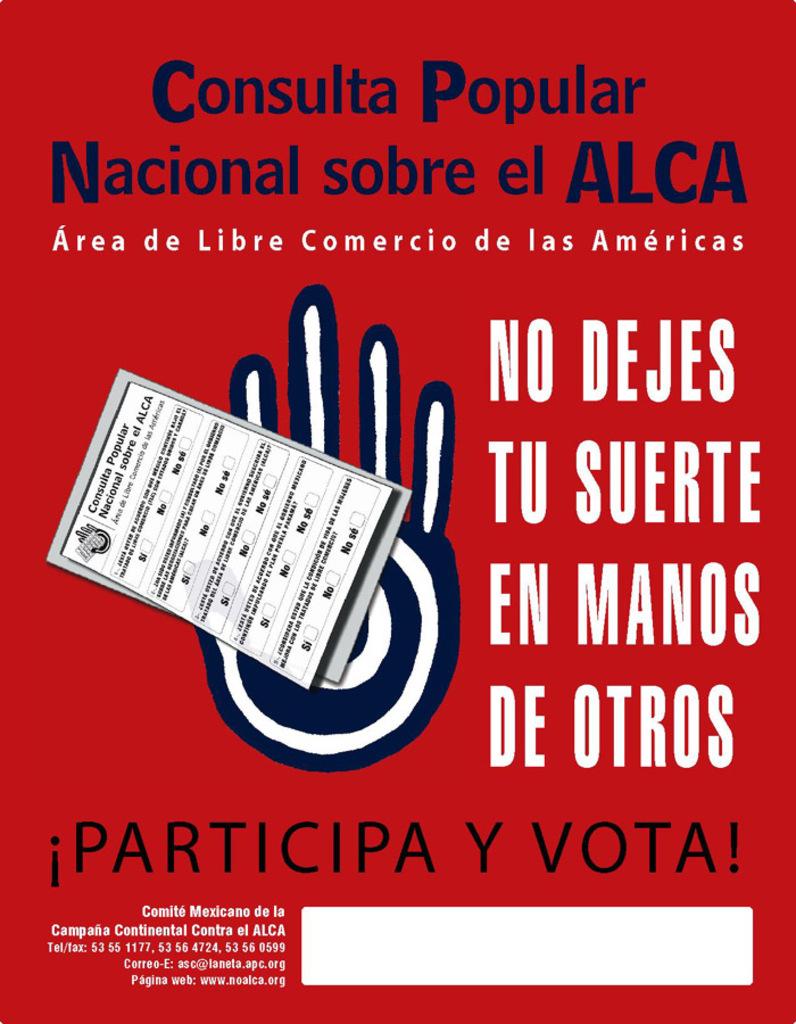What are the two words at the top of the poster?
Ensure brevity in your answer.  Consulta popular. What does this sign want you to do?
Your answer should be compact. Vote. 